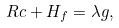Convert formula to latex. <formula><loc_0><loc_0><loc_500><loc_500>R c + H _ { f } = \lambda g ,</formula> 